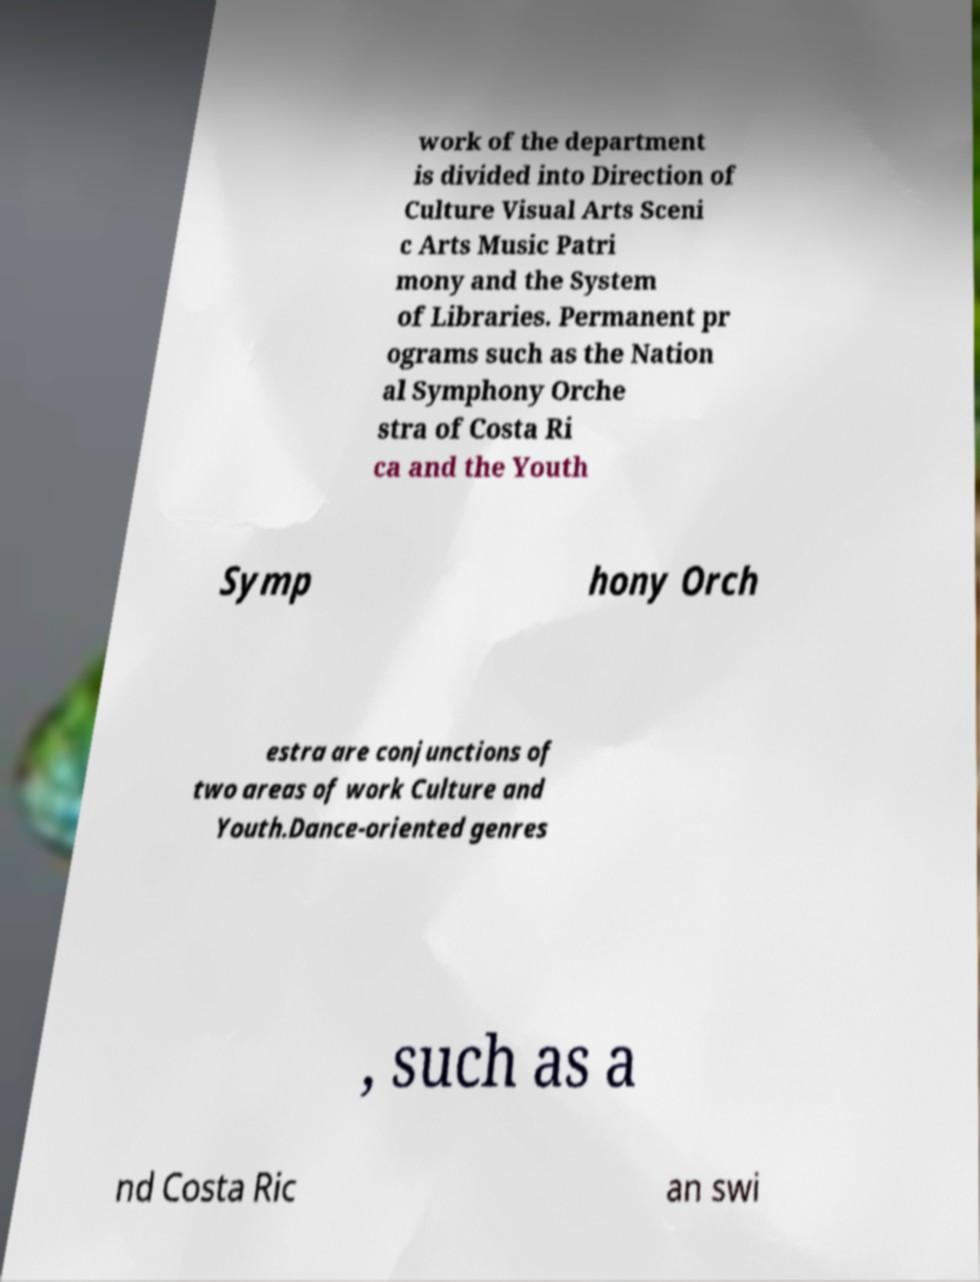Could you assist in decoding the text presented in this image and type it out clearly? work of the department is divided into Direction of Culture Visual Arts Sceni c Arts Music Patri mony and the System of Libraries. Permanent pr ograms such as the Nation al Symphony Orche stra of Costa Ri ca and the Youth Symp hony Orch estra are conjunctions of two areas of work Culture and Youth.Dance-oriented genres , such as a nd Costa Ric an swi 